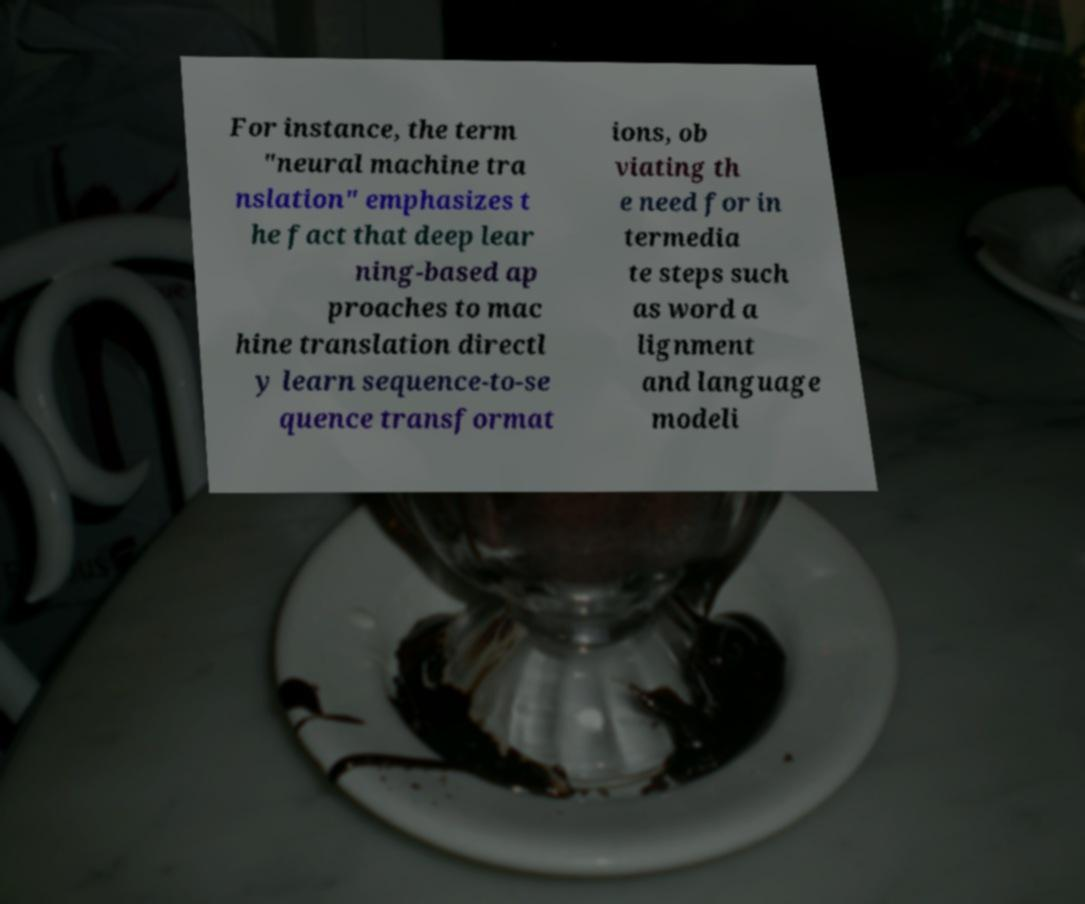Could you assist in decoding the text presented in this image and type it out clearly? For instance, the term "neural machine tra nslation" emphasizes t he fact that deep lear ning-based ap proaches to mac hine translation directl y learn sequence-to-se quence transformat ions, ob viating th e need for in termedia te steps such as word a lignment and language modeli 